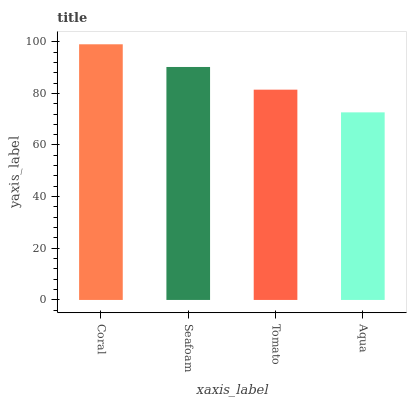Is Seafoam the minimum?
Answer yes or no. No. Is Seafoam the maximum?
Answer yes or no. No. Is Coral greater than Seafoam?
Answer yes or no. Yes. Is Seafoam less than Coral?
Answer yes or no. Yes. Is Seafoam greater than Coral?
Answer yes or no. No. Is Coral less than Seafoam?
Answer yes or no. No. Is Seafoam the high median?
Answer yes or no. Yes. Is Tomato the low median?
Answer yes or no. Yes. Is Aqua the high median?
Answer yes or no. No. Is Coral the low median?
Answer yes or no. No. 